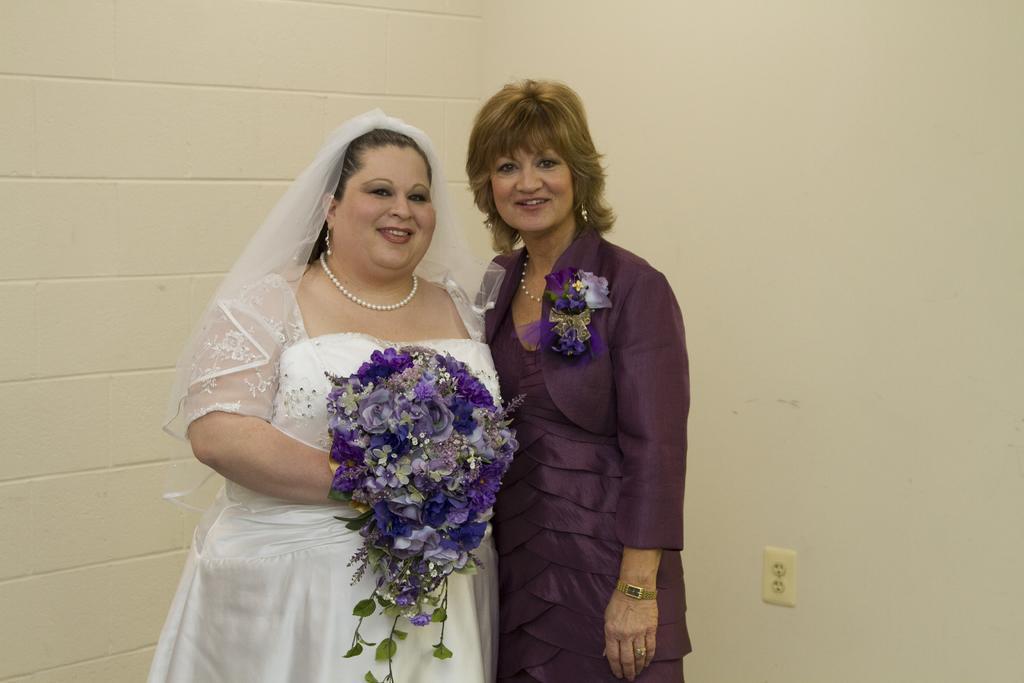How would you summarize this image in a sentence or two? In the picture we can see two women standing side by side and smiling and one woman is wearing a white dress, and holding a flower book in her hand and another woman is wearing a blue dress and in the background we can see a wall which is white in color with a switchboard. 